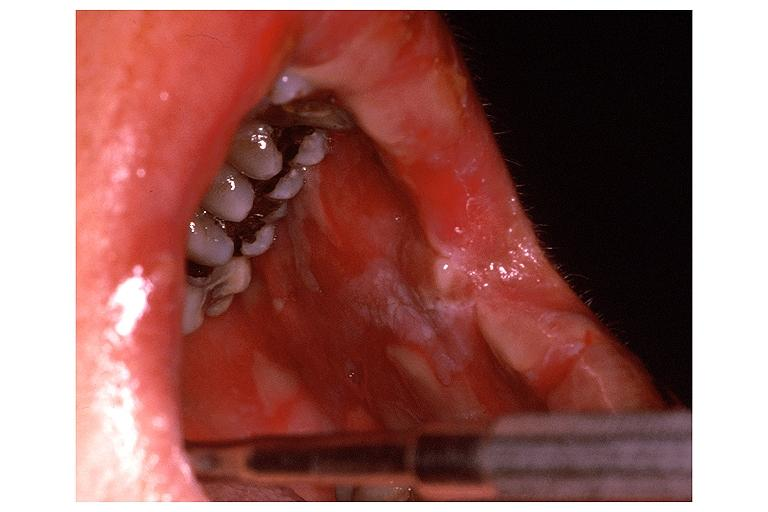does cm show erythema multiforme?
Answer the question using a single word or phrase. No 